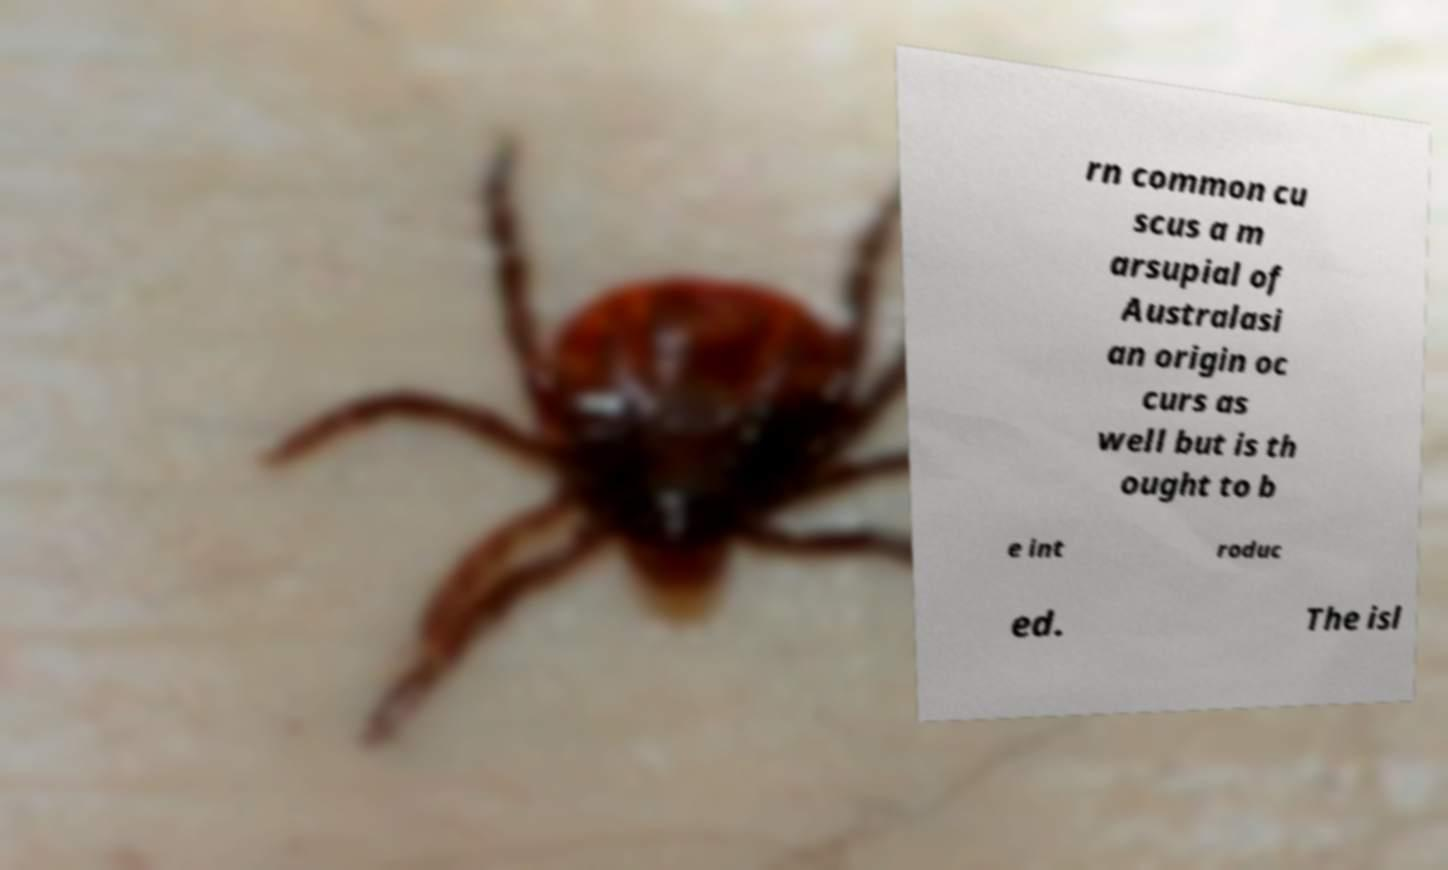For documentation purposes, I need the text within this image transcribed. Could you provide that? rn common cu scus a m arsupial of Australasi an origin oc curs as well but is th ought to b e int roduc ed. The isl 